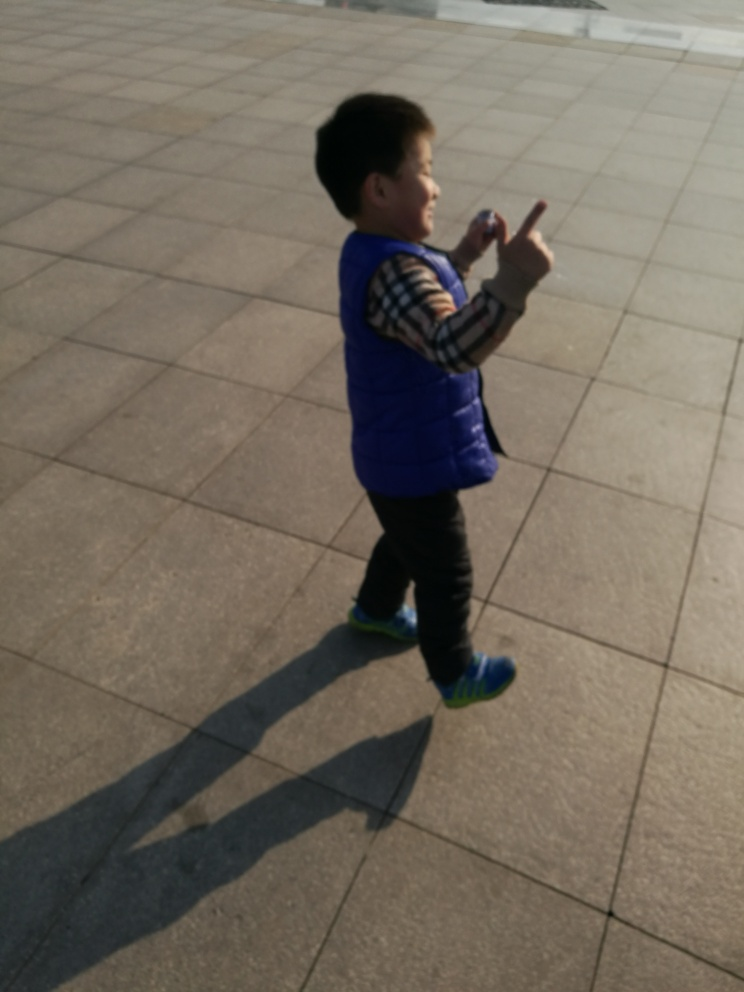What time of day does this image look like it was taken? The long shadows and the warm, soft light suggest that this image was likely taken in the late afternoon, possibly during the 'golden hour' shortly before sunset, which is known for its photogenic lighting. 